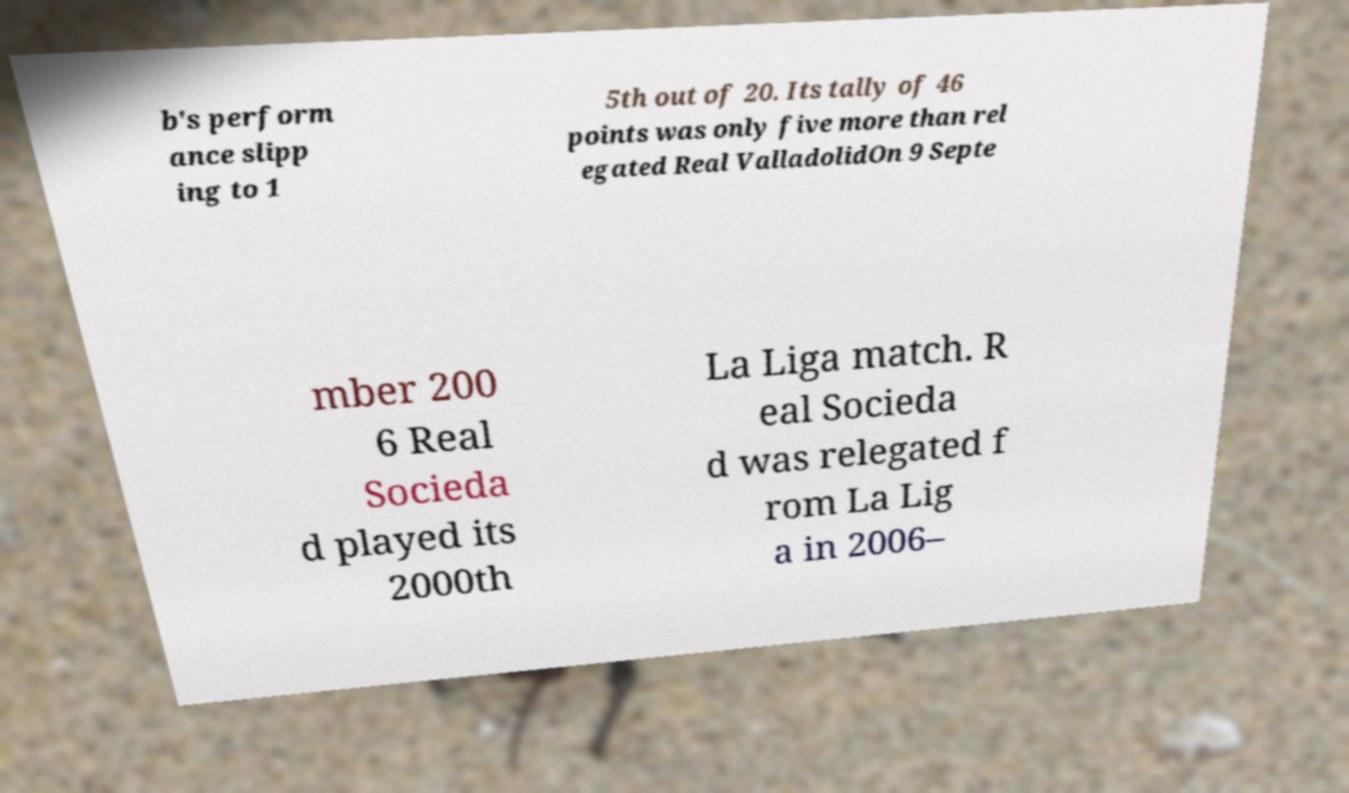Please read and relay the text visible in this image. What does it say? b's perform ance slipp ing to 1 5th out of 20. Its tally of 46 points was only five more than rel egated Real ValladolidOn 9 Septe mber 200 6 Real Socieda d played its 2000th La Liga match. R eal Socieda d was relegated f rom La Lig a in 2006– 